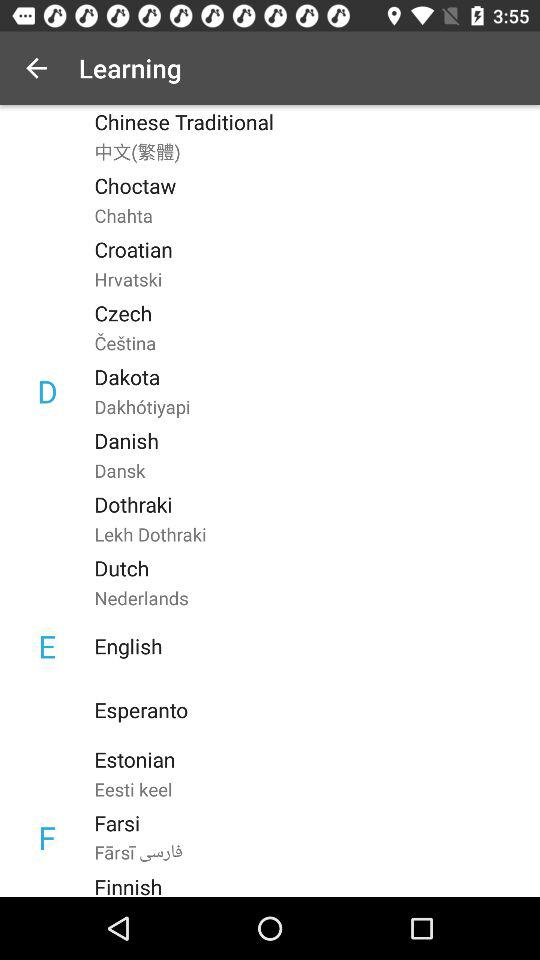What is the app's name? The app's name is "HelloTalk". 